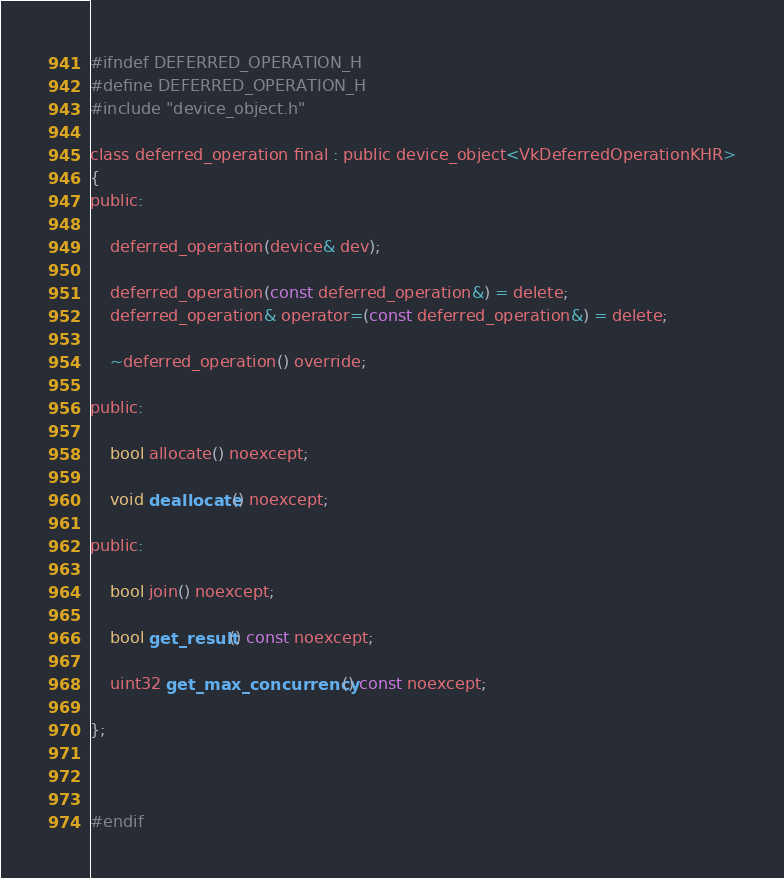<code> <loc_0><loc_0><loc_500><loc_500><_C_>#ifndef DEFERRED_OPERATION_H
#define DEFERRED_OPERATION_H
#include "device_object.h"

class deferred_operation final : public device_object<VkDeferredOperationKHR>
{
public:

	deferred_operation(device& dev);

	deferred_operation(const deferred_operation&) = delete;
	deferred_operation& operator=(const deferred_operation&) = delete;

	~deferred_operation() override;

public:

	bool allocate() noexcept;

	void deallocate() noexcept;

public:

	bool join() noexcept;

	bool get_result() const noexcept;

	uint32 get_max_concurrency() const noexcept;
	
};



#endif</code> 